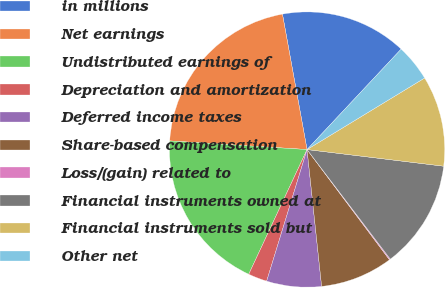Convert chart to OTSL. <chart><loc_0><loc_0><loc_500><loc_500><pie_chart><fcel>in millions<fcel>Net earnings<fcel>Undistributed earnings of<fcel>Depreciation and amortization<fcel>Deferred income taxes<fcel>Share-based compensation<fcel>Loss/(gain) related to<fcel>Financial instruments owned at<fcel>Financial instruments sold but<fcel>Other net<nl><fcel>14.84%<fcel>21.14%<fcel>19.04%<fcel>2.22%<fcel>6.43%<fcel>8.53%<fcel>0.12%<fcel>12.73%<fcel>10.63%<fcel>4.32%<nl></chart> 